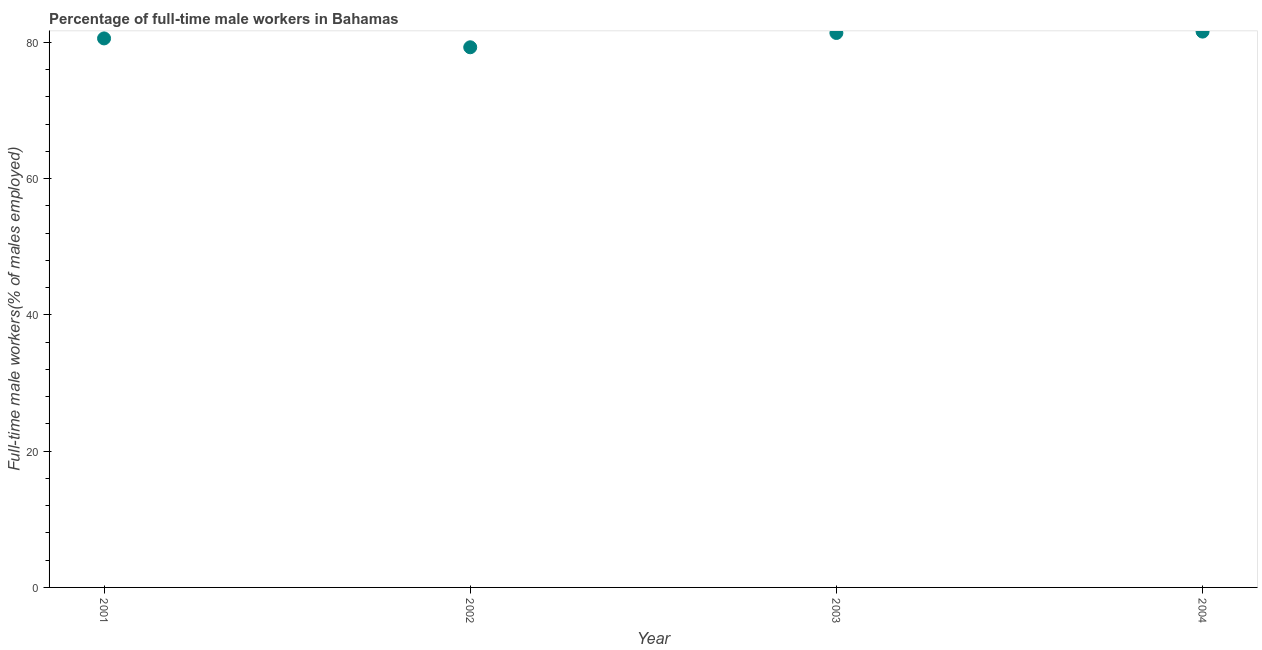What is the percentage of full-time male workers in 2003?
Keep it short and to the point. 81.4. Across all years, what is the maximum percentage of full-time male workers?
Offer a terse response. 81.6. Across all years, what is the minimum percentage of full-time male workers?
Your response must be concise. 79.3. In which year was the percentage of full-time male workers maximum?
Offer a terse response. 2004. In which year was the percentage of full-time male workers minimum?
Your answer should be very brief. 2002. What is the sum of the percentage of full-time male workers?
Make the answer very short. 322.9. What is the difference between the percentage of full-time male workers in 2001 and 2004?
Offer a terse response. -1. What is the average percentage of full-time male workers per year?
Offer a very short reply. 80.73. What is the median percentage of full-time male workers?
Your response must be concise. 81. In how many years, is the percentage of full-time male workers greater than 52 %?
Your response must be concise. 4. What is the ratio of the percentage of full-time male workers in 2001 to that in 2003?
Your response must be concise. 0.99. What is the difference between the highest and the second highest percentage of full-time male workers?
Your answer should be very brief. 0.2. What is the difference between the highest and the lowest percentage of full-time male workers?
Provide a short and direct response. 2.3. How many dotlines are there?
Make the answer very short. 1. How many years are there in the graph?
Offer a terse response. 4. What is the difference between two consecutive major ticks on the Y-axis?
Provide a short and direct response. 20. Are the values on the major ticks of Y-axis written in scientific E-notation?
Provide a short and direct response. No. Does the graph contain grids?
Make the answer very short. No. What is the title of the graph?
Provide a short and direct response. Percentage of full-time male workers in Bahamas. What is the label or title of the X-axis?
Offer a very short reply. Year. What is the label or title of the Y-axis?
Ensure brevity in your answer.  Full-time male workers(% of males employed). What is the Full-time male workers(% of males employed) in 2001?
Your answer should be very brief. 80.6. What is the Full-time male workers(% of males employed) in 2002?
Your answer should be compact. 79.3. What is the Full-time male workers(% of males employed) in 2003?
Your answer should be compact. 81.4. What is the Full-time male workers(% of males employed) in 2004?
Your response must be concise. 81.6. What is the difference between the Full-time male workers(% of males employed) in 2001 and 2002?
Ensure brevity in your answer.  1.3. What is the difference between the Full-time male workers(% of males employed) in 2001 and 2003?
Your answer should be very brief. -0.8. What is the ratio of the Full-time male workers(% of males employed) in 2001 to that in 2004?
Your response must be concise. 0.99. What is the ratio of the Full-time male workers(% of males employed) in 2002 to that in 2003?
Your answer should be very brief. 0.97. What is the ratio of the Full-time male workers(% of males employed) in 2002 to that in 2004?
Your answer should be very brief. 0.97. 